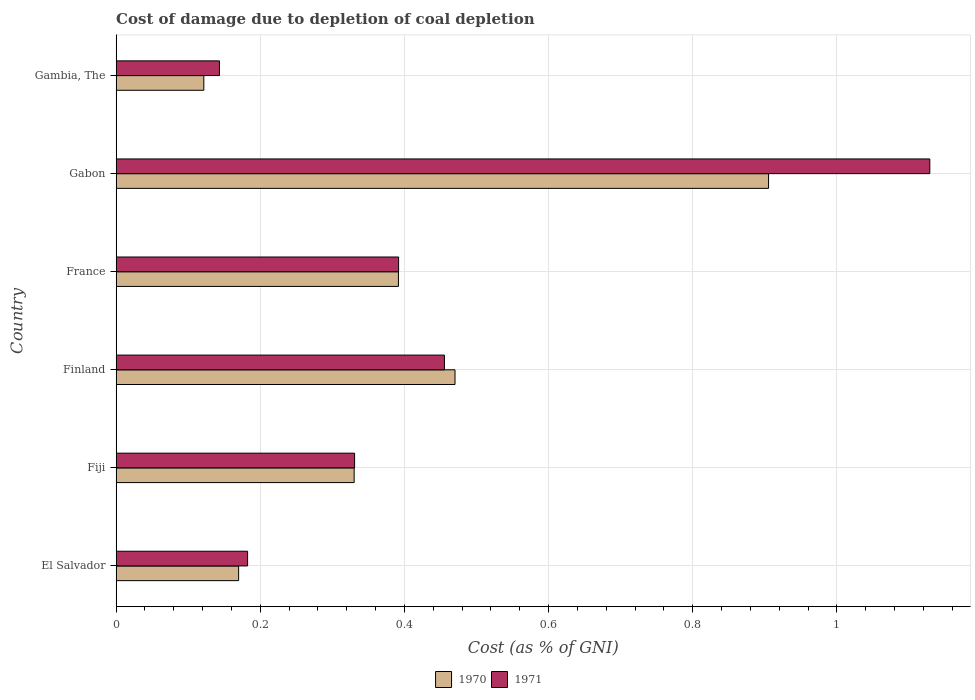How many bars are there on the 3rd tick from the top?
Make the answer very short. 2. What is the label of the 5th group of bars from the top?
Provide a succinct answer. Fiji. In how many cases, is the number of bars for a given country not equal to the number of legend labels?
Offer a terse response. 0. What is the cost of damage caused due to coal depletion in 1971 in Gambia, The?
Offer a terse response. 0.14. Across all countries, what is the maximum cost of damage caused due to coal depletion in 1970?
Make the answer very short. 0.91. Across all countries, what is the minimum cost of damage caused due to coal depletion in 1971?
Your response must be concise. 0.14. In which country was the cost of damage caused due to coal depletion in 1971 maximum?
Make the answer very short. Gabon. In which country was the cost of damage caused due to coal depletion in 1971 minimum?
Keep it short and to the point. Gambia, The. What is the total cost of damage caused due to coal depletion in 1971 in the graph?
Your response must be concise. 2.63. What is the difference between the cost of damage caused due to coal depletion in 1971 in Fiji and that in France?
Make the answer very short. -0.06. What is the difference between the cost of damage caused due to coal depletion in 1971 in Gambia, The and the cost of damage caused due to coal depletion in 1970 in France?
Your answer should be compact. -0.25. What is the average cost of damage caused due to coal depletion in 1970 per country?
Offer a very short reply. 0.4. What is the difference between the cost of damage caused due to coal depletion in 1970 and cost of damage caused due to coal depletion in 1971 in France?
Provide a short and direct response. -0. What is the ratio of the cost of damage caused due to coal depletion in 1971 in France to that in Gambia, The?
Your answer should be compact. 2.73. What is the difference between the highest and the second highest cost of damage caused due to coal depletion in 1971?
Your answer should be compact. 0.67. What is the difference between the highest and the lowest cost of damage caused due to coal depletion in 1970?
Provide a short and direct response. 0.78. In how many countries, is the cost of damage caused due to coal depletion in 1971 greater than the average cost of damage caused due to coal depletion in 1971 taken over all countries?
Ensure brevity in your answer.  2. Is the sum of the cost of damage caused due to coal depletion in 1971 in El Salvador and Fiji greater than the maximum cost of damage caused due to coal depletion in 1970 across all countries?
Offer a very short reply. No. What does the 1st bar from the bottom in Finland represents?
Your response must be concise. 1970. How many bars are there?
Provide a succinct answer. 12. What is the difference between two consecutive major ticks on the X-axis?
Keep it short and to the point. 0.2. Are the values on the major ticks of X-axis written in scientific E-notation?
Offer a terse response. No. Where does the legend appear in the graph?
Offer a terse response. Bottom center. How many legend labels are there?
Your answer should be compact. 2. How are the legend labels stacked?
Your response must be concise. Horizontal. What is the title of the graph?
Provide a short and direct response. Cost of damage due to depletion of coal depletion. What is the label or title of the X-axis?
Give a very brief answer. Cost (as % of GNI). What is the label or title of the Y-axis?
Your response must be concise. Country. What is the Cost (as % of GNI) in 1970 in El Salvador?
Provide a short and direct response. 0.17. What is the Cost (as % of GNI) in 1971 in El Salvador?
Keep it short and to the point. 0.18. What is the Cost (as % of GNI) of 1970 in Fiji?
Provide a succinct answer. 0.33. What is the Cost (as % of GNI) in 1971 in Fiji?
Your answer should be very brief. 0.33. What is the Cost (as % of GNI) in 1970 in Finland?
Offer a very short reply. 0.47. What is the Cost (as % of GNI) in 1971 in Finland?
Keep it short and to the point. 0.46. What is the Cost (as % of GNI) in 1970 in France?
Ensure brevity in your answer.  0.39. What is the Cost (as % of GNI) of 1971 in France?
Ensure brevity in your answer.  0.39. What is the Cost (as % of GNI) in 1970 in Gabon?
Give a very brief answer. 0.91. What is the Cost (as % of GNI) in 1971 in Gabon?
Keep it short and to the point. 1.13. What is the Cost (as % of GNI) in 1970 in Gambia, The?
Provide a short and direct response. 0.12. What is the Cost (as % of GNI) in 1971 in Gambia, The?
Your response must be concise. 0.14. Across all countries, what is the maximum Cost (as % of GNI) of 1970?
Make the answer very short. 0.91. Across all countries, what is the maximum Cost (as % of GNI) of 1971?
Keep it short and to the point. 1.13. Across all countries, what is the minimum Cost (as % of GNI) in 1970?
Make the answer very short. 0.12. Across all countries, what is the minimum Cost (as % of GNI) in 1971?
Ensure brevity in your answer.  0.14. What is the total Cost (as % of GNI) of 1970 in the graph?
Provide a short and direct response. 2.39. What is the total Cost (as % of GNI) in 1971 in the graph?
Your answer should be very brief. 2.63. What is the difference between the Cost (as % of GNI) of 1970 in El Salvador and that in Fiji?
Provide a short and direct response. -0.16. What is the difference between the Cost (as % of GNI) of 1971 in El Salvador and that in Fiji?
Your answer should be compact. -0.15. What is the difference between the Cost (as % of GNI) in 1970 in El Salvador and that in Finland?
Offer a very short reply. -0.3. What is the difference between the Cost (as % of GNI) in 1971 in El Salvador and that in Finland?
Your answer should be compact. -0.27. What is the difference between the Cost (as % of GNI) in 1970 in El Salvador and that in France?
Give a very brief answer. -0.22. What is the difference between the Cost (as % of GNI) of 1971 in El Salvador and that in France?
Provide a short and direct response. -0.21. What is the difference between the Cost (as % of GNI) in 1970 in El Salvador and that in Gabon?
Keep it short and to the point. -0.74. What is the difference between the Cost (as % of GNI) of 1971 in El Salvador and that in Gabon?
Your answer should be very brief. -0.95. What is the difference between the Cost (as % of GNI) of 1970 in El Salvador and that in Gambia, The?
Your answer should be very brief. 0.05. What is the difference between the Cost (as % of GNI) of 1971 in El Salvador and that in Gambia, The?
Make the answer very short. 0.04. What is the difference between the Cost (as % of GNI) in 1970 in Fiji and that in Finland?
Your answer should be very brief. -0.14. What is the difference between the Cost (as % of GNI) in 1971 in Fiji and that in Finland?
Offer a terse response. -0.12. What is the difference between the Cost (as % of GNI) of 1970 in Fiji and that in France?
Make the answer very short. -0.06. What is the difference between the Cost (as % of GNI) of 1971 in Fiji and that in France?
Provide a succinct answer. -0.06. What is the difference between the Cost (as % of GNI) in 1970 in Fiji and that in Gabon?
Offer a terse response. -0.57. What is the difference between the Cost (as % of GNI) in 1971 in Fiji and that in Gabon?
Offer a terse response. -0.8. What is the difference between the Cost (as % of GNI) of 1970 in Fiji and that in Gambia, The?
Your answer should be compact. 0.21. What is the difference between the Cost (as % of GNI) in 1971 in Fiji and that in Gambia, The?
Ensure brevity in your answer.  0.19. What is the difference between the Cost (as % of GNI) in 1970 in Finland and that in France?
Your answer should be compact. 0.08. What is the difference between the Cost (as % of GNI) of 1971 in Finland and that in France?
Your answer should be very brief. 0.06. What is the difference between the Cost (as % of GNI) in 1970 in Finland and that in Gabon?
Your answer should be compact. -0.43. What is the difference between the Cost (as % of GNI) of 1971 in Finland and that in Gabon?
Your answer should be compact. -0.67. What is the difference between the Cost (as % of GNI) in 1970 in Finland and that in Gambia, The?
Make the answer very short. 0.35. What is the difference between the Cost (as % of GNI) in 1971 in Finland and that in Gambia, The?
Keep it short and to the point. 0.31. What is the difference between the Cost (as % of GNI) in 1970 in France and that in Gabon?
Give a very brief answer. -0.51. What is the difference between the Cost (as % of GNI) in 1971 in France and that in Gabon?
Ensure brevity in your answer.  -0.74. What is the difference between the Cost (as % of GNI) in 1970 in France and that in Gambia, The?
Keep it short and to the point. 0.27. What is the difference between the Cost (as % of GNI) in 1971 in France and that in Gambia, The?
Make the answer very short. 0.25. What is the difference between the Cost (as % of GNI) of 1970 in Gabon and that in Gambia, The?
Your answer should be compact. 0.78. What is the difference between the Cost (as % of GNI) in 1971 in Gabon and that in Gambia, The?
Give a very brief answer. 0.99. What is the difference between the Cost (as % of GNI) of 1970 in El Salvador and the Cost (as % of GNI) of 1971 in Fiji?
Your answer should be very brief. -0.16. What is the difference between the Cost (as % of GNI) in 1970 in El Salvador and the Cost (as % of GNI) in 1971 in Finland?
Your response must be concise. -0.29. What is the difference between the Cost (as % of GNI) in 1970 in El Salvador and the Cost (as % of GNI) in 1971 in France?
Your answer should be compact. -0.22. What is the difference between the Cost (as % of GNI) in 1970 in El Salvador and the Cost (as % of GNI) in 1971 in Gabon?
Provide a short and direct response. -0.96. What is the difference between the Cost (as % of GNI) of 1970 in El Salvador and the Cost (as % of GNI) of 1971 in Gambia, The?
Make the answer very short. 0.03. What is the difference between the Cost (as % of GNI) of 1970 in Fiji and the Cost (as % of GNI) of 1971 in Finland?
Offer a terse response. -0.13. What is the difference between the Cost (as % of GNI) in 1970 in Fiji and the Cost (as % of GNI) in 1971 in France?
Give a very brief answer. -0.06. What is the difference between the Cost (as % of GNI) of 1970 in Fiji and the Cost (as % of GNI) of 1971 in Gabon?
Provide a short and direct response. -0.8. What is the difference between the Cost (as % of GNI) in 1970 in Fiji and the Cost (as % of GNI) in 1971 in Gambia, The?
Your answer should be very brief. 0.19. What is the difference between the Cost (as % of GNI) of 1970 in Finland and the Cost (as % of GNI) of 1971 in France?
Keep it short and to the point. 0.08. What is the difference between the Cost (as % of GNI) of 1970 in Finland and the Cost (as % of GNI) of 1971 in Gabon?
Offer a terse response. -0.66. What is the difference between the Cost (as % of GNI) in 1970 in Finland and the Cost (as % of GNI) in 1971 in Gambia, The?
Offer a very short reply. 0.33. What is the difference between the Cost (as % of GNI) in 1970 in France and the Cost (as % of GNI) in 1971 in Gabon?
Offer a very short reply. -0.74. What is the difference between the Cost (as % of GNI) in 1970 in France and the Cost (as % of GNI) in 1971 in Gambia, The?
Offer a terse response. 0.25. What is the difference between the Cost (as % of GNI) of 1970 in Gabon and the Cost (as % of GNI) of 1971 in Gambia, The?
Your response must be concise. 0.76. What is the average Cost (as % of GNI) of 1970 per country?
Ensure brevity in your answer.  0.4. What is the average Cost (as % of GNI) in 1971 per country?
Give a very brief answer. 0.44. What is the difference between the Cost (as % of GNI) of 1970 and Cost (as % of GNI) of 1971 in El Salvador?
Give a very brief answer. -0.01. What is the difference between the Cost (as % of GNI) in 1970 and Cost (as % of GNI) in 1971 in Fiji?
Provide a succinct answer. -0. What is the difference between the Cost (as % of GNI) of 1970 and Cost (as % of GNI) of 1971 in Finland?
Provide a short and direct response. 0.01. What is the difference between the Cost (as % of GNI) of 1970 and Cost (as % of GNI) of 1971 in France?
Keep it short and to the point. -0. What is the difference between the Cost (as % of GNI) in 1970 and Cost (as % of GNI) in 1971 in Gabon?
Provide a succinct answer. -0.22. What is the difference between the Cost (as % of GNI) of 1970 and Cost (as % of GNI) of 1971 in Gambia, The?
Your answer should be compact. -0.02. What is the ratio of the Cost (as % of GNI) of 1970 in El Salvador to that in Fiji?
Make the answer very short. 0.51. What is the ratio of the Cost (as % of GNI) in 1971 in El Salvador to that in Fiji?
Ensure brevity in your answer.  0.55. What is the ratio of the Cost (as % of GNI) of 1970 in El Salvador to that in Finland?
Ensure brevity in your answer.  0.36. What is the ratio of the Cost (as % of GNI) of 1971 in El Salvador to that in Finland?
Offer a very short reply. 0.4. What is the ratio of the Cost (as % of GNI) of 1970 in El Salvador to that in France?
Your response must be concise. 0.43. What is the ratio of the Cost (as % of GNI) in 1971 in El Salvador to that in France?
Your answer should be compact. 0.47. What is the ratio of the Cost (as % of GNI) of 1970 in El Salvador to that in Gabon?
Keep it short and to the point. 0.19. What is the ratio of the Cost (as % of GNI) in 1971 in El Salvador to that in Gabon?
Offer a terse response. 0.16. What is the ratio of the Cost (as % of GNI) of 1970 in El Salvador to that in Gambia, The?
Offer a terse response. 1.4. What is the ratio of the Cost (as % of GNI) of 1971 in El Salvador to that in Gambia, The?
Provide a short and direct response. 1.27. What is the ratio of the Cost (as % of GNI) in 1970 in Fiji to that in Finland?
Provide a short and direct response. 0.7. What is the ratio of the Cost (as % of GNI) in 1971 in Fiji to that in Finland?
Offer a terse response. 0.73. What is the ratio of the Cost (as % of GNI) of 1970 in Fiji to that in France?
Keep it short and to the point. 0.84. What is the ratio of the Cost (as % of GNI) in 1971 in Fiji to that in France?
Provide a succinct answer. 0.84. What is the ratio of the Cost (as % of GNI) of 1970 in Fiji to that in Gabon?
Provide a short and direct response. 0.36. What is the ratio of the Cost (as % of GNI) in 1971 in Fiji to that in Gabon?
Your answer should be compact. 0.29. What is the ratio of the Cost (as % of GNI) in 1970 in Fiji to that in Gambia, The?
Make the answer very short. 2.71. What is the ratio of the Cost (as % of GNI) in 1971 in Fiji to that in Gambia, The?
Your response must be concise. 2.31. What is the ratio of the Cost (as % of GNI) of 1970 in Finland to that in France?
Make the answer very short. 1.2. What is the ratio of the Cost (as % of GNI) in 1971 in Finland to that in France?
Your answer should be compact. 1.16. What is the ratio of the Cost (as % of GNI) of 1970 in Finland to that in Gabon?
Offer a very short reply. 0.52. What is the ratio of the Cost (as % of GNI) in 1971 in Finland to that in Gabon?
Your answer should be compact. 0.4. What is the ratio of the Cost (as % of GNI) of 1970 in Finland to that in Gambia, The?
Provide a short and direct response. 3.86. What is the ratio of the Cost (as % of GNI) of 1971 in Finland to that in Gambia, The?
Ensure brevity in your answer.  3.18. What is the ratio of the Cost (as % of GNI) in 1970 in France to that in Gabon?
Keep it short and to the point. 0.43. What is the ratio of the Cost (as % of GNI) of 1971 in France to that in Gabon?
Offer a terse response. 0.35. What is the ratio of the Cost (as % of GNI) in 1970 in France to that in Gambia, The?
Your response must be concise. 3.22. What is the ratio of the Cost (as % of GNI) of 1971 in France to that in Gambia, The?
Give a very brief answer. 2.73. What is the ratio of the Cost (as % of GNI) in 1970 in Gabon to that in Gambia, The?
Make the answer very short. 7.44. What is the ratio of the Cost (as % of GNI) in 1971 in Gabon to that in Gambia, The?
Give a very brief answer. 7.88. What is the difference between the highest and the second highest Cost (as % of GNI) of 1970?
Keep it short and to the point. 0.43. What is the difference between the highest and the second highest Cost (as % of GNI) of 1971?
Give a very brief answer. 0.67. What is the difference between the highest and the lowest Cost (as % of GNI) in 1970?
Your answer should be compact. 0.78. What is the difference between the highest and the lowest Cost (as % of GNI) of 1971?
Provide a succinct answer. 0.99. 